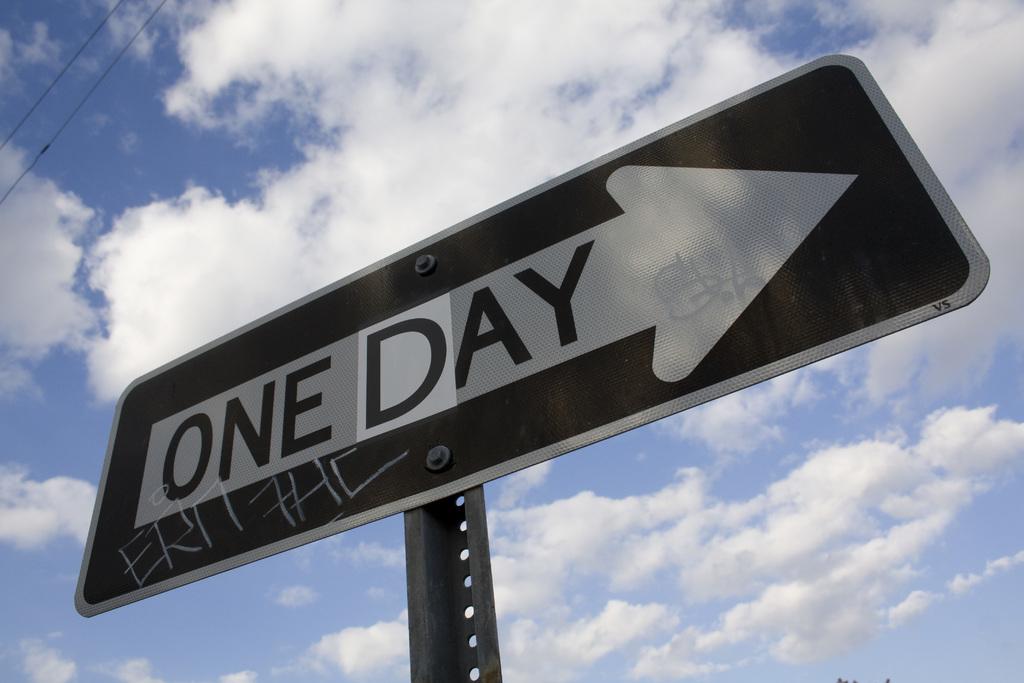Does this sign say one way?
Make the answer very short. No. What is written on the bottom right of the sign?
Your answer should be very brief. Unanswerable. 